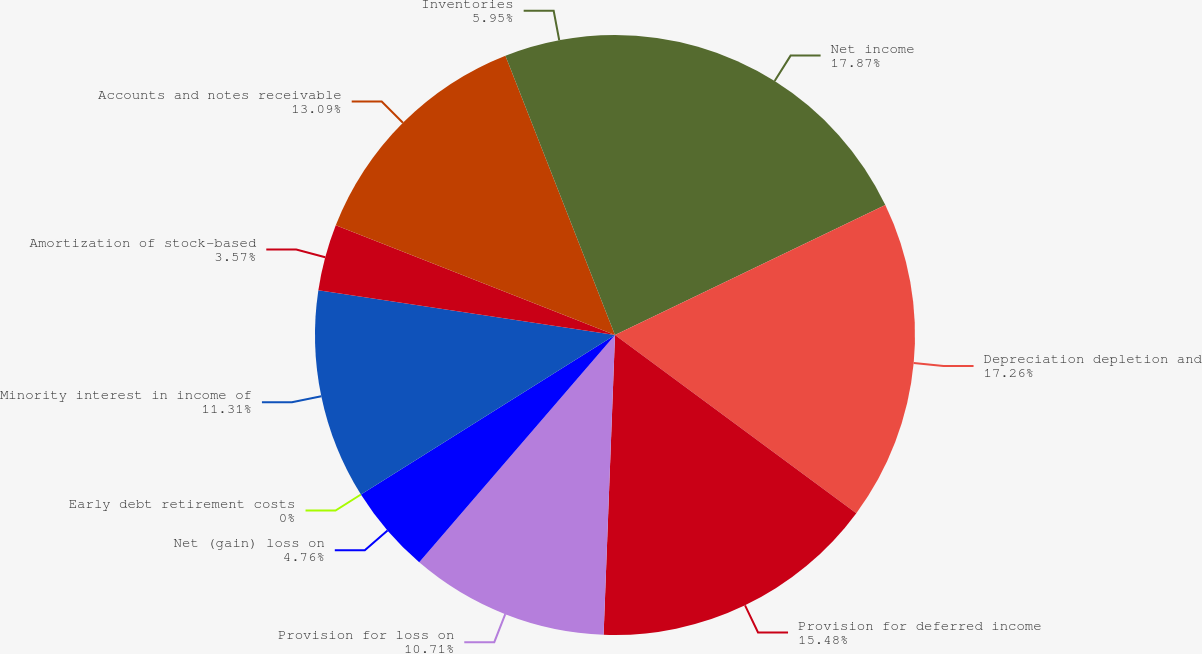Convert chart to OTSL. <chart><loc_0><loc_0><loc_500><loc_500><pie_chart><fcel>Net income<fcel>Depreciation depletion and<fcel>Provision for deferred income<fcel>Provision for loss on<fcel>Net (gain) loss on<fcel>Early debt retirement costs<fcel>Minority interest in income of<fcel>Amortization of stock-based<fcel>Accounts and notes receivable<fcel>Inventories<nl><fcel>17.86%<fcel>17.26%<fcel>15.48%<fcel>10.71%<fcel>4.76%<fcel>0.0%<fcel>11.31%<fcel>3.57%<fcel>13.09%<fcel>5.95%<nl></chart> 